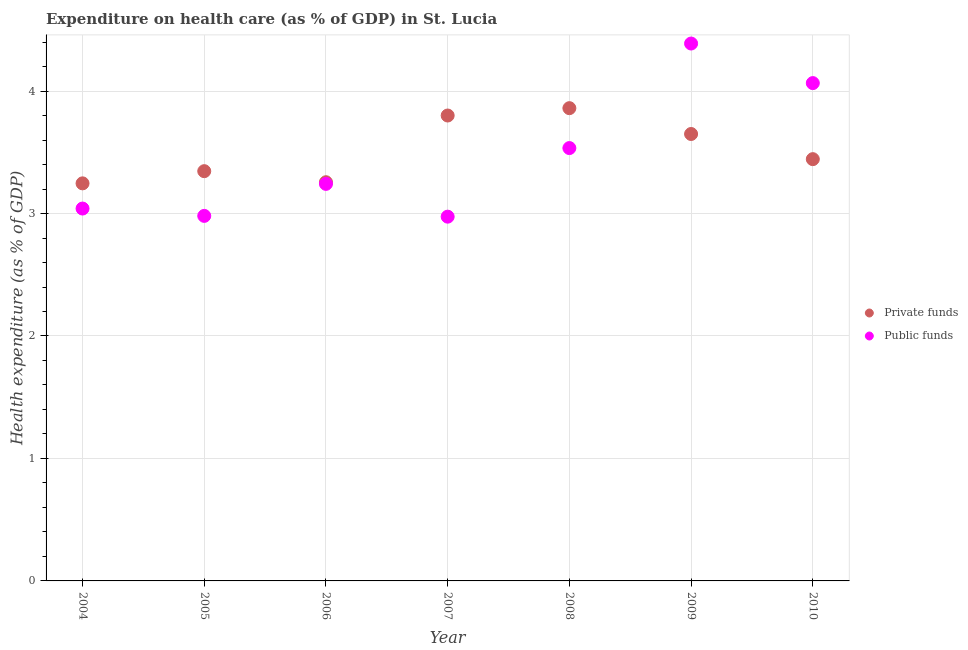Is the number of dotlines equal to the number of legend labels?
Your answer should be very brief. Yes. What is the amount of private funds spent in healthcare in 2009?
Ensure brevity in your answer.  3.65. Across all years, what is the maximum amount of public funds spent in healthcare?
Give a very brief answer. 4.39. Across all years, what is the minimum amount of private funds spent in healthcare?
Provide a succinct answer. 3.25. What is the total amount of public funds spent in healthcare in the graph?
Your answer should be compact. 24.23. What is the difference between the amount of public funds spent in healthcare in 2004 and that in 2005?
Ensure brevity in your answer.  0.06. What is the difference between the amount of private funds spent in healthcare in 2007 and the amount of public funds spent in healthcare in 2004?
Keep it short and to the point. 0.76. What is the average amount of private funds spent in healthcare per year?
Your response must be concise. 3.51. In the year 2004, what is the difference between the amount of public funds spent in healthcare and amount of private funds spent in healthcare?
Your answer should be compact. -0.21. In how many years, is the amount of private funds spent in healthcare greater than 3 %?
Make the answer very short. 7. What is the ratio of the amount of private funds spent in healthcare in 2008 to that in 2010?
Offer a terse response. 1.12. Is the amount of private funds spent in healthcare in 2004 less than that in 2009?
Your answer should be very brief. Yes. Is the difference between the amount of private funds spent in healthcare in 2005 and 2007 greater than the difference between the amount of public funds spent in healthcare in 2005 and 2007?
Your answer should be compact. No. What is the difference between the highest and the second highest amount of private funds spent in healthcare?
Your answer should be very brief. 0.06. What is the difference between the highest and the lowest amount of private funds spent in healthcare?
Give a very brief answer. 0.61. Is the sum of the amount of private funds spent in healthcare in 2004 and 2010 greater than the maximum amount of public funds spent in healthcare across all years?
Offer a very short reply. Yes. Does the amount of public funds spent in healthcare monotonically increase over the years?
Offer a terse response. No. Is the amount of private funds spent in healthcare strictly greater than the amount of public funds spent in healthcare over the years?
Ensure brevity in your answer.  No. How many dotlines are there?
Offer a terse response. 2. How many years are there in the graph?
Your answer should be compact. 7. What is the title of the graph?
Make the answer very short. Expenditure on health care (as % of GDP) in St. Lucia. Does "Working only" appear as one of the legend labels in the graph?
Your answer should be very brief. No. What is the label or title of the X-axis?
Make the answer very short. Year. What is the label or title of the Y-axis?
Give a very brief answer. Health expenditure (as % of GDP). What is the Health expenditure (as % of GDP) of Private funds in 2004?
Make the answer very short. 3.25. What is the Health expenditure (as % of GDP) of Public funds in 2004?
Make the answer very short. 3.04. What is the Health expenditure (as % of GDP) in Private funds in 2005?
Provide a succinct answer. 3.35. What is the Health expenditure (as % of GDP) of Public funds in 2005?
Your answer should be compact. 2.98. What is the Health expenditure (as % of GDP) of Private funds in 2006?
Give a very brief answer. 3.26. What is the Health expenditure (as % of GDP) in Public funds in 2006?
Your answer should be compact. 3.24. What is the Health expenditure (as % of GDP) of Private funds in 2007?
Your answer should be very brief. 3.8. What is the Health expenditure (as % of GDP) in Public funds in 2007?
Offer a terse response. 2.97. What is the Health expenditure (as % of GDP) of Private funds in 2008?
Your response must be concise. 3.86. What is the Health expenditure (as % of GDP) of Public funds in 2008?
Keep it short and to the point. 3.53. What is the Health expenditure (as % of GDP) in Private funds in 2009?
Provide a short and direct response. 3.65. What is the Health expenditure (as % of GDP) in Public funds in 2009?
Your answer should be compact. 4.39. What is the Health expenditure (as % of GDP) of Private funds in 2010?
Your answer should be compact. 3.44. What is the Health expenditure (as % of GDP) in Public funds in 2010?
Give a very brief answer. 4.07. Across all years, what is the maximum Health expenditure (as % of GDP) in Private funds?
Provide a short and direct response. 3.86. Across all years, what is the maximum Health expenditure (as % of GDP) of Public funds?
Provide a short and direct response. 4.39. Across all years, what is the minimum Health expenditure (as % of GDP) in Private funds?
Your response must be concise. 3.25. Across all years, what is the minimum Health expenditure (as % of GDP) of Public funds?
Your answer should be compact. 2.97. What is the total Health expenditure (as % of GDP) of Private funds in the graph?
Ensure brevity in your answer.  24.6. What is the total Health expenditure (as % of GDP) in Public funds in the graph?
Offer a very short reply. 24.23. What is the difference between the Health expenditure (as % of GDP) in Private funds in 2004 and that in 2005?
Your answer should be very brief. -0.1. What is the difference between the Health expenditure (as % of GDP) of Public funds in 2004 and that in 2005?
Make the answer very short. 0.06. What is the difference between the Health expenditure (as % of GDP) in Private funds in 2004 and that in 2006?
Provide a short and direct response. -0.01. What is the difference between the Health expenditure (as % of GDP) of Public funds in 2004 and that in 2006?
Keep it short and to the point. -0.2. What is the difference between the Health expenditure (as % of GDP) in Private funds in 2004 and that in 2007?
Your answer should be very brief. -0.55. What is the difference between the Health expenditure (as % of GDP) in Public funds in 2004 and that in 2007?
Keep it short and to the point. 0.07. What is the difference between the Health expenditure (as % of GDP) of Private funds in 2004 and that in 2008?
Offer a terse response. -0.61. What is the difference between the Health expenditure (as % of GDP) in Public funds in 2004 and that in 2008?
Ensure brevity in your answer.  -0.49. What is the difference between the Health expenditure (as % of GDP) in Private funds in 2004 and that in 2009?
Your answer should be compact. -0.4. What is the difference between the Health expenditure (as % of GDP) of Public funds in 2004 and that in 2009?
Provide a succinct answer. -1.35. What is the difference between the Health expenditure (as % of GDP) in Private funds in 2004 and that in 2010?
Offer a terse response. -0.2. What is the difference between the Health expenditure (as % of GDP) in Public funds in 2004 and that in 2010?
Provide a succinct answer. -1.02. What is the difference between the Health expenditure (as % of GDP) in Private funds in 2005 and that in 2006?
Your answer should be very brief. 0.09. What is the difference between the Health expenditure (as % of GDP) of Public funds in 2005 and that in 2006?
Ensure brevity in your answer.  -0.26. What is the difference between the Health expenditure (as % of GDP) in Private funds in 2005 and that in 2007?
Your answer should be compact. -0.45. What is the difference between the Health expenditure (as % of GDP) in Public funds in 2005 and that in 2007?
Offer a terse response. 0.01. What is the difference between the Health expenditure (as % of GDP) of Private funds in 2005 and that in 2008?
Your response must be concise. -0.51. What is the difference between the Health expenditure (as % of GDP) of Public funds in 2005 and that in 2008?
Provide a short and direct response. -0.55. What is the difference between the Health expenditure (as % of GDP) in Private funds in 2005 and that in 2009?
Ensure brevity in your answer.  -0.3. What is the difference between the Health expenditure (as % of GDP) in Public funds in 2005 and that in 2009?
Provide a short and direct response. -1.41. What is the difference between the Health expenditure (as % of GDP) of Private funds in 2005 and that in 2010?
Your answer should be compact. -0.1. What is the difference between the Health expenditure (as % of GDP) in Public funds in 2005 and that in 2010?
Make the answer very short. -1.08. What is the difference between the Health expenditure (as % of GDP) of Private funds in 2006 and that in 2007?
Offer a terse response. -0.54. What is the difference between the Health expenditure (as % of GDP) of Public funds in 2006 and that in 2007?
Your answer should be compact. 0.27. What is the difference between the Health expenditure (as % of GDP) in Private funds in 2006 and that in 2008?
Offer a terse response. -0.6. What is the difference between the Health expenditure (as % of GDP) in Public funds in 2006 and that in 2008?
Make the answer very short. -0.29. What is the difference between the Health expenditure (as % of GDP) in Private funds in 2006 and that in 2009?
Ensure brevity in your answer.  -0.39. What is the difference between the Health expenditure (as % of GDP) in Public funds in 2006 and that in 2009?
Provide a short and direct response. -1.15. What is the difference between the Health expenditure (as % of GDP) in Private funds in 2006 and that in 2010?
Make the answer very short. -0.19. What is the difference between the Health expenditure (as % of GDP) in Public funds in 2006 and that in 2010?
Provide a succinct answer. -0.82. What is the difference between the Health expenditure (as % of GDP) in Private funds in 2007 and that in 2008?
Your answer should be very brief. -0.06. What is the difference between the Health expenditure (as % of GDP) in Public funds in 2007 and that in 2008?
Your answer should be compact. -0.56. What is the difference between the Health expenditure (as % of GDP) of Private funds in 2007 and that in 2009?
Your answer should be compact. 0.15. What is the difference between the Health expenditure (as % of GDP) in Public funds in 2007 and that in 2009?
Offer a very short reply. -1.41. What is the difference between the Health expenditure (as % of GDP) of Private funds in 2007 and that in 2010?
Provide a short and direct response. 0.36. What is the difference between the Health expenditure (as % of GDP) of Public funds in 2007 and that in 2010?
Give a very brief answer. -1.09. What is the difference between the Health expenditure (as % of GDP) in Private funds in 2008 and that in 2009?
Ensure brevity in your answer.  0.21. What is the difference between the Health expenditure (as % of GDP) in Public funds in 2008 and that in 2009?
Make the answer very short. -0.85. What is the difference between the Health expenditure (as % of GDP) of Private funds in 2008 and that in 2010?
Keep it short and to the point. 0.42. What is the difference between the Health expenditure (as % of GDP) in Public funds in 2008 and that in 2010?
Provide a short and direct response. -0.53. What is the difference between the Health expenditure (as % of GDP) of Private funds in 2009 and that in 2010?
Make the answer very short. 0.21. What is the difference between the Health expenditure (as % of GDP) in Public funds in 2009 and that in 2010?
Your response must be concise. 0.32. What is the difference between the Health expenditure (as % of GDP) of Private funds in 2004 and the Health expenditure (as % of GDP) of Public funds in 2005?
Offer a terse response. 0.27. What is the difference between the Health expenditure (as % of GDP) of Private funds in 2004 and the Health expenditure (as % of GDP) of Public funds in 2006?
Your answer should be compact. 0. What is the difference between the Health expenditure (as % of GDP) of Private funds in 2004 and the Health expenditure (as % of GDP) of Public funds in 2007?
Ensure brevity in your answer.  0.27. What is the difference between the Health expenditure (as % of GDP) in Private funds in 2004 and the Health expenditure (as % of GDP) in Public funds in 2008?
Your answer should be compact. -0.29. What is the difference between the Health expenditure (as % of GDP) in Private funds in 2004 and the Health expenditure (as % of GDP) in Public funds in 2009?
Your response must be concise. -1.14. What is the difference between the Health expenditure (as % of GDP) in Private funds in 2004 and the Health expenditure (as % of GDP) in Public funds in 2010?
Ensure brevity in your answer.  -0.82. What is the difference between the Health expenditure (as % of GDP) in Private funds in 2005 and the Health expenditure (as % of GDP) in Public funds in 2006?
Your answer should be compact. 0.1. What is the difference between the Health expenditure (as % of GDP) of Private funds in 2005 and the Health expenditure (as % of GDP) of Public funds in 2007?
Offer a terse response. 0.37. What is the difference between the Health expenditure (as % of GDP) in Private funds in 2005 and the Health expenditure (as % of GDP) in Public funds in 2008?
Offer a very short reply. -0.19. What is the difference between the Health expenditure (as % of GDP) of Private funds in 2005 and the Health expenditure (as % of GDP) of Public funds in 2009?
Your answer should be very brief. -1.04. What is the difference between the Health expenditure (as % of GDP) in Private funds in 2005 and the Health expenditure (as % of GDP) in Public funds in 2010?
Offer a terse response. -0.72. What is the difference between the Health expenditure (as % of GDP) in Private funds in 2006 and the Health expenditure (as % of GDP) in Public funds in 2007?
Your answer should be compact. 0.28. What is the difference between the Health expenditure (as % of GDP) of Private funds in 2006 and the Health expenditure (as % of GDP) of Public funds in 2008?
Offer a very short reply. -0.28. What is the difference between the Health expenditure (as % of GDP) in Private funds in 2006 and the Health expenditure (as % of GDP) in Public funds in 2009?
Offer a very short reply. -1.13. What is the difference between the Health expenditure (as % of GDP) in Private funds in 2006 and the Health expenditure (as % of GDP) in Public funds in 2010?
Offer a terse response. -0.81. What is the difference between the Health expenditure (as % of GDP) in Private funds in 2007 and the Health expenditure (as % of GDP) in Public funds in 2008?
Give a very brief answer. 0.27. What is the difference between the Health expenditure (as % of GDP) of Private funds in 2007 and the Health expenditure (as % of GDP) of Public funds in 2009?
Offer a terse response. -0.59. What is the difference between the Health expenditure (as % of GDP) of Private funds in 2007 and the Health expenditure (as % of GDP) of Public funds in 2010?
Your answer should be compact. -0.26. What is the difference between the Health expenditure (as % of GDP) in Private funds in 2008 and the Health expenditure (as % of GDP) in Public funds in 2009?
Your answer should be compact. -0.53. What is the difference between the Health expenditure (as % of GDP) of Private funds in 2008 and the Health expenditure (as % of GDP) of Public funds in 2010?
Provide a succinct answer. -0.2. What is the difference between the Health expenditure (as % of GDP) of Private funds in 2009 and the Health expenditure (as % of GDP) of Public funds in 2010?
Your answer should be very brief. -0.42. What is the average Health expenditure (as % of GDP) in Private funds per year?
Give a very brief answer. 3.51. What is the average Health expenditure (as % of GDP) in Public funds per year?
Your answer should be very brief. 3.46. In the year 2004, what is the difference between the Health expenditure (as % of GDP) of Private funds and Health expenditure (as % of GDP) of Public funds?
Make the answer very short. 0.21. In the year 2005, what is the difference between the Health expenditure (as % of GDP) of Private funds and Health expenditure (as % of GDP) of Public funds?
Offer a terse response. 0.37. In the year 2006, what is the difference between the Health expenditure (as % of GDP) of Private funds and Health expenditure (as % of GDP) of Public funds?
Give a very brief answer. 0.01. In the year 2007, what is the difference between the Health expenditure (as % of GDP) of Private funds and Health expenditure (as % of GDP) of Public funds?
Provide a short and direct response. 0.83. In the year 2008, what is the difference between the Health expenditure (as % of GDP) of Private funds and Health expenditure (as % of GDP) of Public funds?
Give a very brief answer. 0.33. In the year 2009, what is the difference between the Health expenditure (as % of GDP) of Private funds and Health expenditure (as % of GDP) of Public funds?
Offer a very short reply. -0.74. In the year 2010, what is the difference between the Health expenditure (as % of GDP) of Private funds and Health expenditure (as % of GDP) of Public funds?
Your response must be concise. -0.62. What is the ratio of the Health expenditure (as % of GDP) in Private funds in 2004 to that in 2005?
Give a very brief answer. 0.97. What is the ratio of the Health expenditure (as % of GDP) of Public funds in 2004 to that in 2005?
Keep it short and to the point. 1.02. What is the ratio of the Health expenditure (as % of GDP) in Public funds in 2004 to that in 2006?
Your answer should be compact. 0.94. What is the ratio of the Health expenditure (as % of GDP) of Private funds in 2004 to that in 2007?
Your answer should be compact. 0.85. What is the ratio of the Health expenditure (as % of GDP) of Public funds in 2004 to that in 2007?
Provide a short and direct response. 1.02. What is the ratio of the Health expenditure (as % of GDP) of Private funds in 2004 to that in 2008?
Ensure brevity in your answer.  0.84. What is the ratio of the Health expenditure (as % of GDP) of Public funds in 2004 to that in 2008?
Provide a succinct answer. 0.86. What is the ratio of the Health expenditure (as % of GDP) of Private funds in 2004 to that in 2009?
Offer a terse response. 0.89. What is the ratio of the Health expenditure (as % of GDP) in Public funds in 2004 to that in 2009?
Give a very brief answer. 0.69. What is the ratio of the Health expenditure (as % of GDP) in Private funds in 2004 to that in 2010?
Ensure brevity in your answer.  0.94. What is the ratio of the Health expenditure (as % of GDP) of Public funds in 2004 to that in 2010?
Your answer should be very brief. 0.75. What is the ratio of the Health expenditure (as % of GDP) in Private funds in 2005 to that in 2006?
Offer a very short reply. 1.03. What is the ratio of the Health expenditure (as % of GDP) in Public funds in 2005 to that in 2006?
Make the answer very short. 0.92. What is the ratio of the Health expenditure (as % of GDP) of Private funds in 2005 to that in 2007?
Make the answer very short. 0.88. What is the ratio of the Health expenditure (as % of GDP) of Private funds in 2005 to that in 2008?
Provide a short and direct response. 0.87. What is the ratio of the Health expenditure (as % of GDP) in Public funds in 2005 to that in 2008?
Give a very brief answer. 0.84. What is the ratio of the Health expenditure (as % of GDP) in Private funds in 2005 to that in 2009?
Offer a very short reply. 0.92. What is the ratio of the Health expenditure (as % of GDP) in Public funds in 2005 to that in 2009?
Keep it short and to the point. 0.68. What is the ratio of the Health expenditure (as % of GDP) in Private funds in 2005 to that in 2010?
Offer a terse response. 0.97. What is the ratio of the Health expenditure (as % of GDP) in Public funds in 2005 to that in 2010?
Give a very brief answer. 0.73. What is the ratio of the Health expenditure (as % of GDP) in Private funds in 2006 to that in 2007?
Give a very brief answer. 0.86. What is the ratio of the Health expenditure (as % of GDP) of Public funds in 2006 to that in 2007?
Your answer should be very brief. 1.09. What is the ratio of the Health expenditure (as % of GDP) of Private funds in 2006 to that in 2008?
Provide a short and direct response. 0.84. What is the ratio of the Health expenditure (as % of GDP) in Public funds in 2006 to that in 2008?
Offer a terse response. 0.92. What is the ratio of the Health expenditure (as % of GDP) in Private funds in 2006 to that in 2009?
Your answer should be compact. 0.89. What is the ratio of the Health expenditure (as % of GDP) in Public funds in 2006 to that in 2009?
Make the answer very short. 0.74. What is the ratio of the Health expenditure (as % of GDP) in Private funds in 2006 to that in 2010?
Your response must be concise. 0.95. What is the ratio of the Health expenditure (as % of GDP) of Public funds in 2006 to that in 2010?
Keep it short and to the point. 0.8. What is the ratio of the Health expenditure (as % of GDP) in Private funds in 2007 to that in 2008?
Give a very brief answer. 0.98. What is the ratio of the Health expenditure (as % of GDP) of Public funds in 2007 to that in 2008?
Make the answer very short. 0.84. What is the ratio of the Health expenditure (as % of GDP) in Private funds in 2007 to that in 2009?
Offer a very short reply. 1.04. What is the ratio of the Health expenditure (as % of GDP) in Public funds in 2007 to that in 2009?
Your answer should be very brief. 0.68. What is the ratio of the Health expenditure (as % of GDP) of Private funds in 2007 to that in 2010?
Your answer should be very brief. 1.1. What is the ratio of the Health expenditure (as % of GDP) in Public funds in 2007 to that in 2010?
Give a very brief answer. 0.73. What is the ratio of the Health expenditure (as % of GDP) in Private funds in 2008 to that in 2009?
Give a very brief answer. 1.06. What is the ratio of the Health expenditure (as % of GDP) of Public funds in 2008 to that in 2009?
Give a very brief answer. 0.81. What is the ratio of the Health expenditure (as % of GDP) in Private funds in 2008 to that in 2010?
Give a very brief answer. 1.12. What is the ratio of the Health expenditure (as % of GDP) in Public funds in 2008 to that in 2010?
Provide a succinct answer. 0.87. What is the ratio of the Health expenditure (as % of GDP) of Private funds in 2009 to that in 2010?
Provide a short and direct response. 1.06. What is the ratio of the Health expenditure (as % of GDP) in Public funds in 2009 to that in 2010?
Your answer should be compact. 1.08. What is the difference between the highest and the second highest Health expenditure (as % of GDP) in Private funds?
Make the answer very short. 0.06. What is the difference between the highest and the second highest Health expenditure (as % of GDP) in Public funds?
Your answer should be very brief. 0.32. What is the difference between the highest and the lowest Health expenditure (as % of GDP) of Private funds?
Your answer should be compact. 0.61. What is the difference between the highest and the lowest Health expenditure (as % of GDP) in Public funds?
Provide a short and direct response. 1.41. 